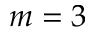<formula> <loc_0><loc_0><loc_500><loc_500>m = 3</formula> 